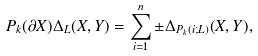<formula> <loc_0><loc_0><loc_500><loc_500>P _ { k } ( \partial X ) \Delta _ { L } ( X , Y ) = \sum _ { i = 1 } ^ { n } \pm \Delta _ { P _ { k } ( i ; L ) } ( X , Y ) ,</formula> 